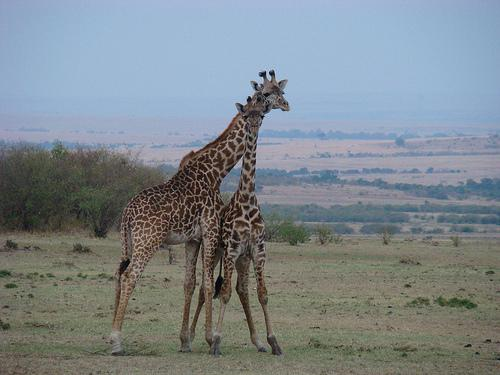Question: what color are the plants behind the giraffe?
Choices:
A. Yellow.
B. White.
C. Green and brown.
D. Red.
Answer with the letter. Answer: C Question: what are the two animals in the picture?
Choices:
A. Zebras.
B. Giraffe.
C. Dogs.
D. Cats.
Answer with the letter. Answer: B Question: how many giraffe are there?
Choices:
A. Three.
B. Four.
C. Two.
D. Seven.
Answer with the letter. Answer: C Question: why is one giraffe smaller?
Choices:
A. It's younger.
B. It's the baby.
C. It eats less.
D. It's sick.
Answer with the letter. Answer: B 